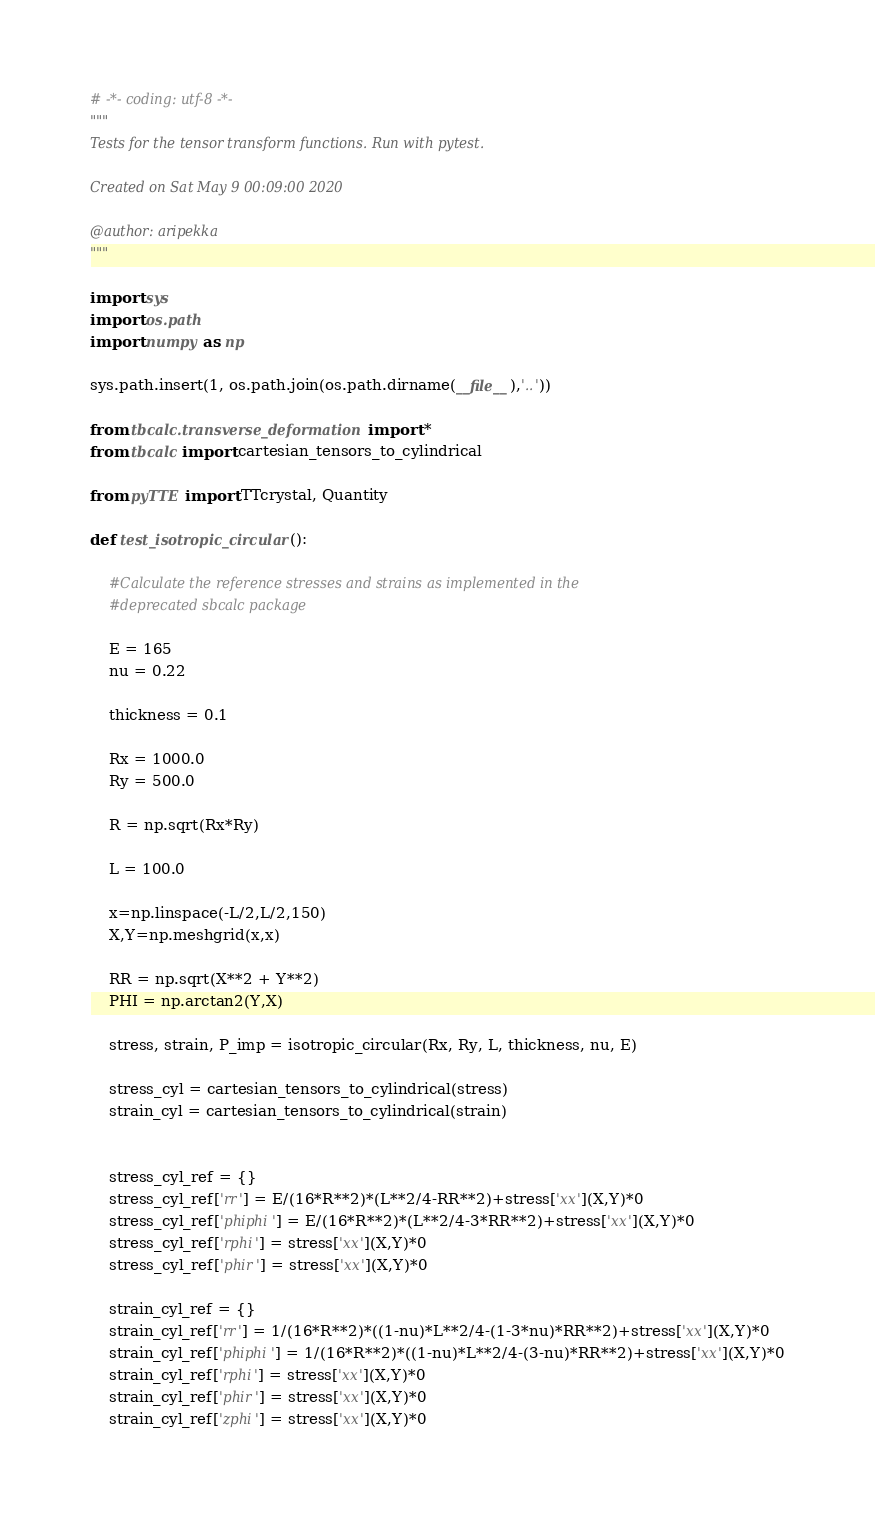Convert code to text. <code><loc_0><loc_0><loc_500><loc_500><_Python_># -*- coding: utf-8 -*-
"""
Tests for the tensor transform functions. Run with pytest.

Created on Sat May 9 00:09:00 2020

@author: aripekka
"""

import sys
import os.path
import numpy as np

sys.path.insert(1, os.path.join(os.path.dirname(__file__),'..'))

from tbcalc.transverse_deformation import * 
from tbcalc import cartesian_tensors_to_cylindrical

from pyTTE import TTcrystal, Quantity

def test_isotropic_circular():

    #Calculate the reference stresses and strains as implemented in the 
    #deprecated sbcalc package

    E = 165
    nu = 0.22

    thickness = 0.1

    Rx = 1000.0
    Ry = 500.0

    R = np.sqrt(Rx*Ry)
 
    L = 100.0   
 
    x=np.linspace(-L/2,L/2,150)
    X,Y=np.meshgrid(x,x)

    RR = np.sqrt(X**2 + Y**2)
    PHI = np.arctan2(Y,X)

    stress, strain, P_imp = isotropic_circular(Rx, Ry, L, thickness, nu, E)

    stress_cyl = cartesian_tensors_to_cylindrical(stress)
    strain_cyl = cartesian_tensors_to_cylindrical(strain)


    stress_cyl_ref = {}
    stress_cyl_ref['rr'] = E/(16*R**2)*(L**2/4-RR**2)+stress['xx'](X,Y)*0
    stress_cyl_ref['phiphi'] = E/(16*R**2)*(L**2/4-3*RR**2)+stress['xx'](X,Y)*0
    stress_cyl_ref['rphi'] = stress['xx'](X,Y)*0
    stress_cyl_ref['phir'] = stress['xx'](X,Y)*0

    strain_cyl_ref = {}
    strain_cyl_ref['rr'] = 1/(16*R**2)*((1-nu)*L**2/4-(1-3*nu)*RR**2)+stress['xx'](X,Y)*0
    strain_cyl_ref['phiphi'] = 1/(16*R**2)*((1-nu)*L**2/4-(3-nu)*RR**2)+stress['xx'](X,Y)*0
    strain_cyl_ref['rphi'] = stress['xx'](X,Y)*0
    strain_cyl_ref['phir'] = stress['xx'](X,Y)*0
    strain_cyl_ref['zphi'] = stress['xx'](X,Y)*0</code> 